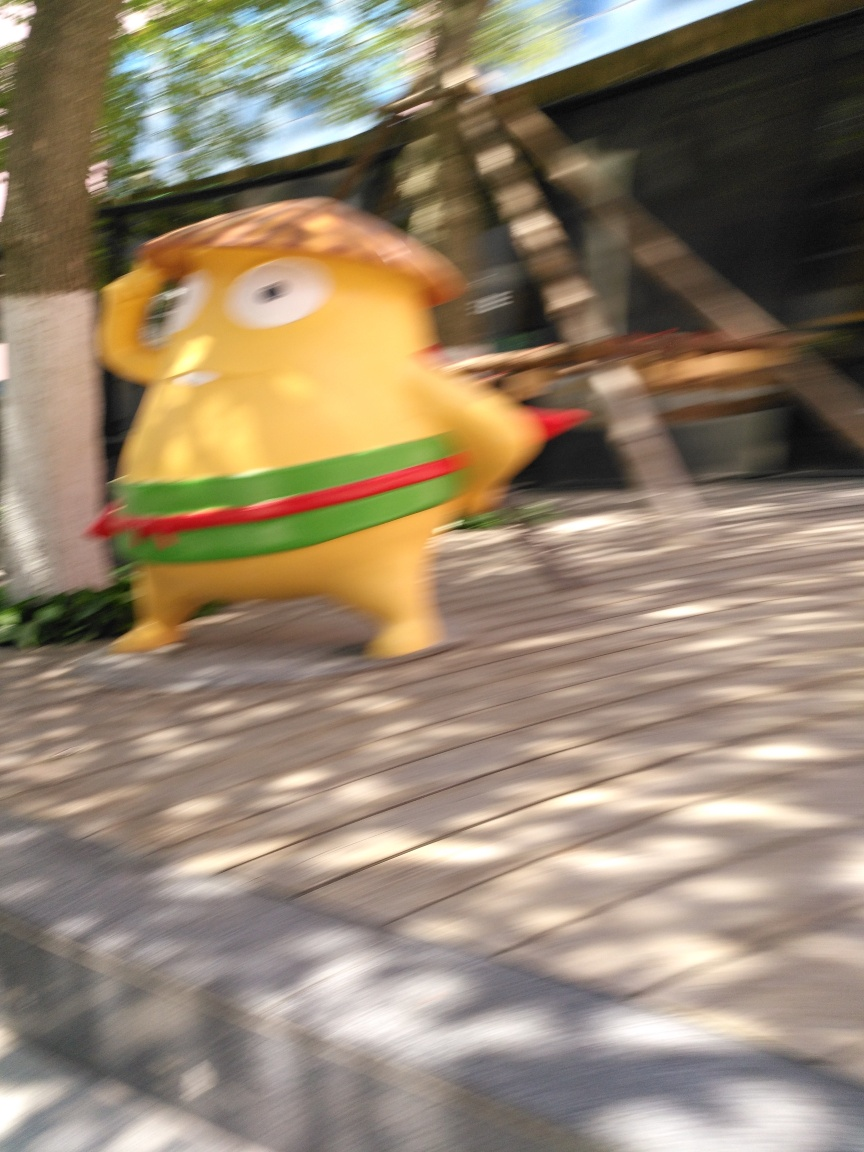How might the motion blur in this image affect its artistic impression? The motion blur generates a feeling of movement and energy. It can convey a sense of rush or urgency and might be intentionally used by a photographer to add artistic flair or emphasize the dynamic nature of the subject. 